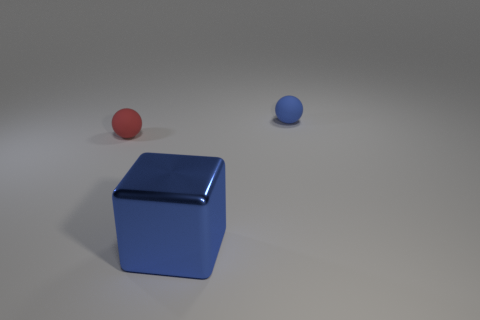Subtract all yellow spheres. Subtract all brown cylinders. How many spheres are left? 2 Add 1 matte objects. How many objects exist? 4 Subtract all spheres. How many objects are left? 1 Add 1 large cubes. How many large cubes exist? 2 Subtract 0 red cylinders. How many objects are left? 3 Subtract all blue blocks. Subtract all matte spheres. How many objects are left? 0 Add 3 blue shiny objects. How many blue shiny objects are left? 4 